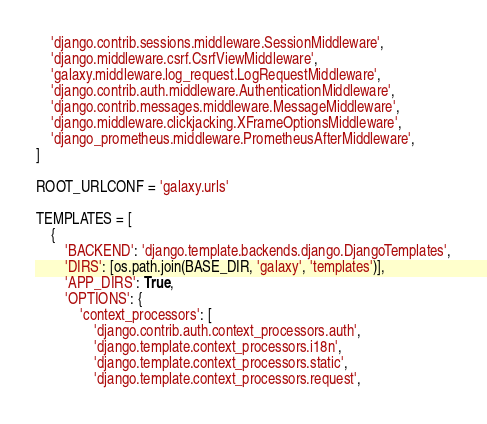Convert code to text. <code><loc_0><loc_0><loc_500><loc_500><_Python_>    'django.contrib.sessions.middleware.SessionMiddleware',
    'django.middleware.csrf.CsrfViewMiddleware',
    'galaxy.middleware.log_request.LogRequestMiddleware',
    'django.contrib.auth.middleware.AuthenticationMiddleware',
    'django.contrib.messages.middleware.MessageMiddleware',
    'django.middleware.clickjacking.XFrameOptionsMiddleware',
    'django_prometheus.middleware.PrometheusAfterMiddleware',
]

ROOT_URLCONF = 'galaxy.urls'

TEMPLATES = [
    {
        'BACKEND': 'django.template.backends.django.DjangoTemplates',
        'DIRS': [os.path.join(BASE_DIR, 'galaxy', 'templates')],
        'APP_DIRS': True,
        'OPTIONS': {
            'context_processors': [
                'django.contrib.auth.context_processors.auth',
                'django.template.context_processors.i18n',
                'django.template.context_processors.static',
                'django.template.context_processors.request',</code> 